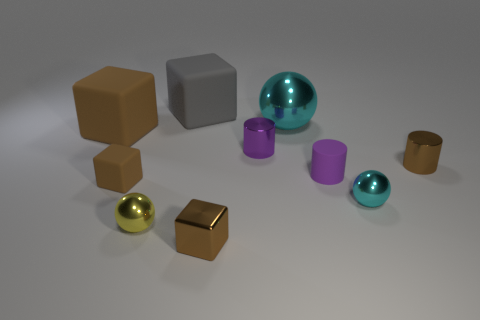Are the big block that is in front of the large cyan thing and the cyan ball on the right side of the big cyan sphere made of the same material?
Offer a very short reply. No. The tiny cyan thing has what shape?
Your response must be concise. Sphere. Are there the same number of tiny cyan spheres to the right of the tiny cyan ball and purple objects?
Your response must be concise. No. There is another ball that is the same color as the big ball; what size is it?
Give a very brief answer. Small. Is there a big purple ball made of the same material as the large cyan thing?
Make the answer very short. No. Is the shape of the tiny rubber object to the right of the tiny metal block the same as the small brown shiny thing to the right of the large cyan sphere?
Your answer should be compact. Yes. Are there any rubber cylinders?
Give a very brief answer. Yes. There is a metallic sphere that is the same size as the gray block; what is its color?
Provide a succinct answer. Cyan. What number of other objects have the same shape as the yellow thing?
Offer a very short reply. 2. Is the material of the small brown thing to the right of the small brown metal block the same as the gray object?
Offer a very short reply. No. 